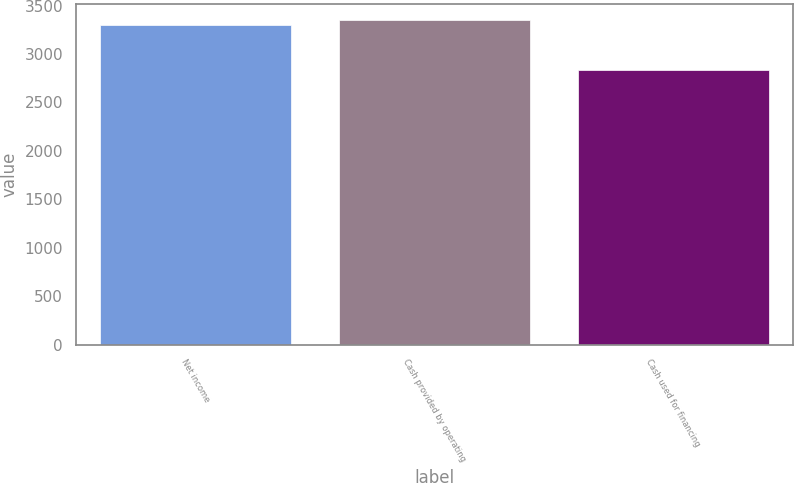Convert chart to OTSL. <chart><loc_0><loc_0><loc_500><loc_500><bar_chart><fcel>Net income<fcel>Cash provided by operating<fcel>Cash used for financing<nl><fcel>3302<fcel>3352.6<fcel>2837<nl></chart> 